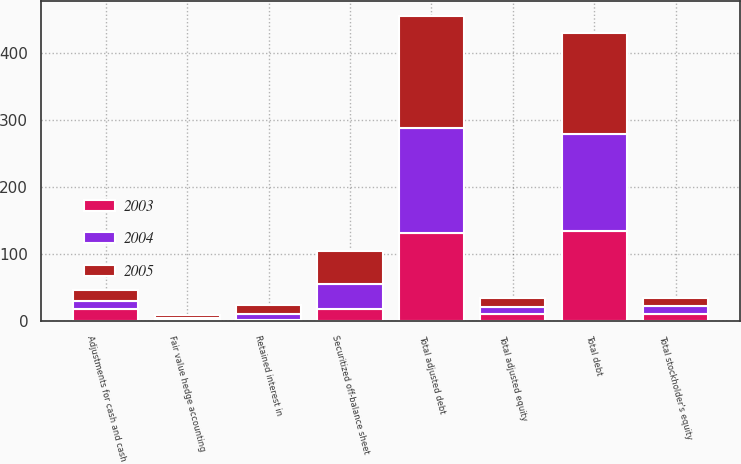Convert chart. <chart><loc_0><loc_0><loc_500><loc_500><stacked_bar_chart><ecel><fcel>Total debt<fcel>Securitized off-balance sheet<fcel>Retained interest in<fcel>Adjustments for cash and cash<fcel>Fair value hedge accounting<fcel>Total adjusted debt<fcel>Total stockholder's equity<fcel>Total adjusted equity<nl><fcel>2003<fcel>134.5<fcel>18<fcel>1.4<fcel>17.9<fcel>1.6<fcel>131.6<fcel>10.7<fcel>10.7<nl><fcel>2004<fcel>144.3<fcel>37.7<fcel>9.5<fcel>12.7<fcel>3.2<fcel>156.6<fcel>11.5<fcel>11.4<nl><fcel>2005<fcel>149.7<fcel>49.4<fcel>13<fcel>15.7<fcel>4.7<fcel>165.7<fcel>12.5<fcel>12.7<nl></chart> 